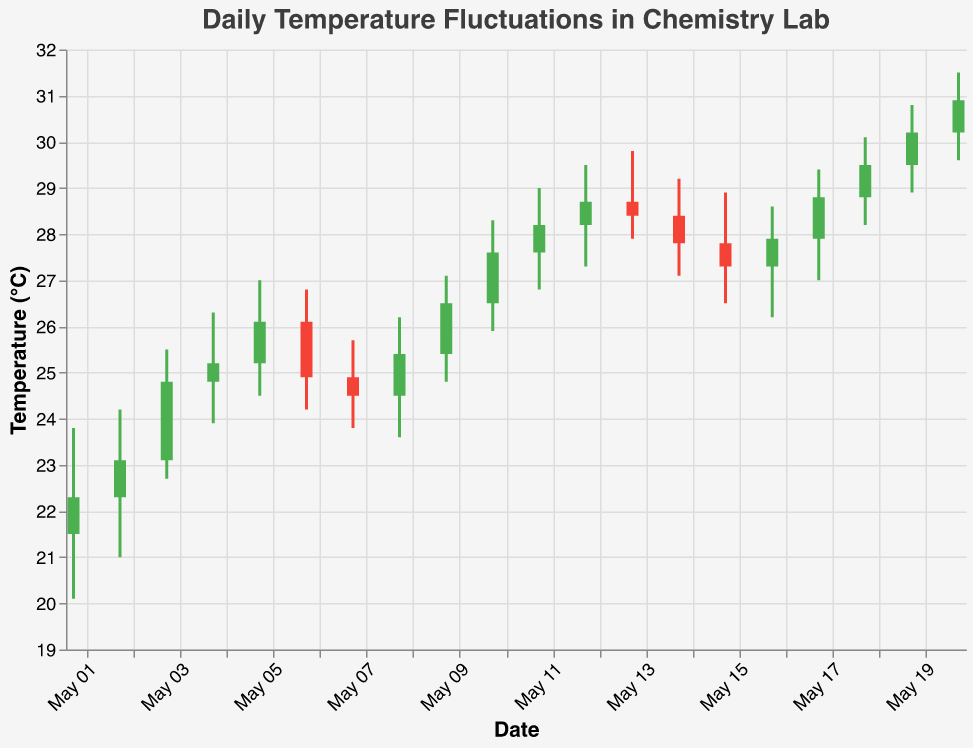What is the title of the chart? The title is always at the top of the chart and in this case, it's clearly stated.
Answer: Daily Temperature Fluctuations in Chemistry Lab What is the highest temperature recorded during the month? The highest temperature is indicated by the highest "High" value in the data, which can be found at the top of each bar on the chart. The highest value is 31.5 on May 20.
Answer: 31.5°C What is the color of the bars when the closing temperature is higher than the opening temperature? The color-condition part of the code determines that when `Close > Open`, the bar is colored green.
Answer: Green On which date did the temperature have the biggest fluctuation and what was the range? The biggest fluctuation is determined by the difference between High and Low values for each day. May 10 has the biggest range, calculated by subtracting the "Low" value from the "High" value (28.3 - 25.9 = 2.4).
Answer: May 10, 2.4°C Which day had the lowest opening temperature and what was it? The lowest opening temperature is the minimum "Open" value present in the data column. May 1 had the lowest opening temperature of 21.5°C.
Answer: May 1, 21.5°C What is the average closing temperature during this period? To find the average, sum all the "Close" values and divide by the number of days. Sum of Close values: 22.3+23.1+24.8+25.2+26.1+24.9+24.5+25.4+26.5+27.6+28.2+28.7+28.4+27.8+27.3+27.9+28.8+29.5+30.2+30.9 = 531.2; Number of days: 20; Average = 531.2 / 20 = 26.56°C.
Answer: 26.56°C How many days had their closing temperature higher than 28°C? Identify all bars where the "Close" value is greater than 28. There are 9 such days: May 11, May 12, May 13, May 14, May 16, May 17, May 18, May 19, and May 20.
Answer: 9 days What color are the bars on May 6 and why? For May 6, `Open` is greater than `Close` (26.1 > 24.9), which according to the color condition, will color the bar red (indicating a drop in temperature).
Answer: Red Which day had the smallest difference between its opening and closing temperatures and what was the difference? Calculate the difference (absolute value) between Open and Close for each date. May 3 has the smallest difference (24.8 - 23.1 = 1.7).
Answer: May 3, 1.7°C 